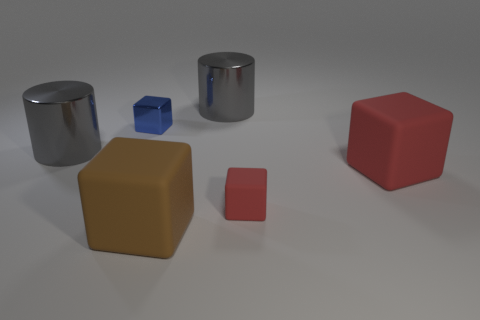There is a small matte object; does it have the same color as the matte block right of the tiny red object?
Provide a succinct answer. Yes. How many things are either small brown cylinders or rubber cubes left of the tiny red cube?
Make the answer very short. 1. What size is the gray metallic thing that is to the right of the gray object in front of the tiny blue object?
Make the answer very short. Large. Is the number of big gray objects that are in front of the small red object the same as the number of big blocks left of the blue thing?
Provide a short and direct response. Yes. There is a red block on the right side of the tiny red cube; are there any large metal objects that are on the right side of it?
Make the answer very short. No. The red thing that is made of the same material as the large red cube is what shape?
Give a very brief answer. Cube. Is there anything else of the same color as the tiny rubber block?
Your answer should be compact. Yes. What is the red cube that is in front of the large rubber thing that is behind the tiny red rubber thing made of?
Keep it short and to the point. Rubber. Is there a large brown rubber object that has the same shape as the blue shiny thing?
Provide a succinct answer. Yes. What number of other objects are the same shape as the big brown rubber thing?
Your response must be concise. 3. 